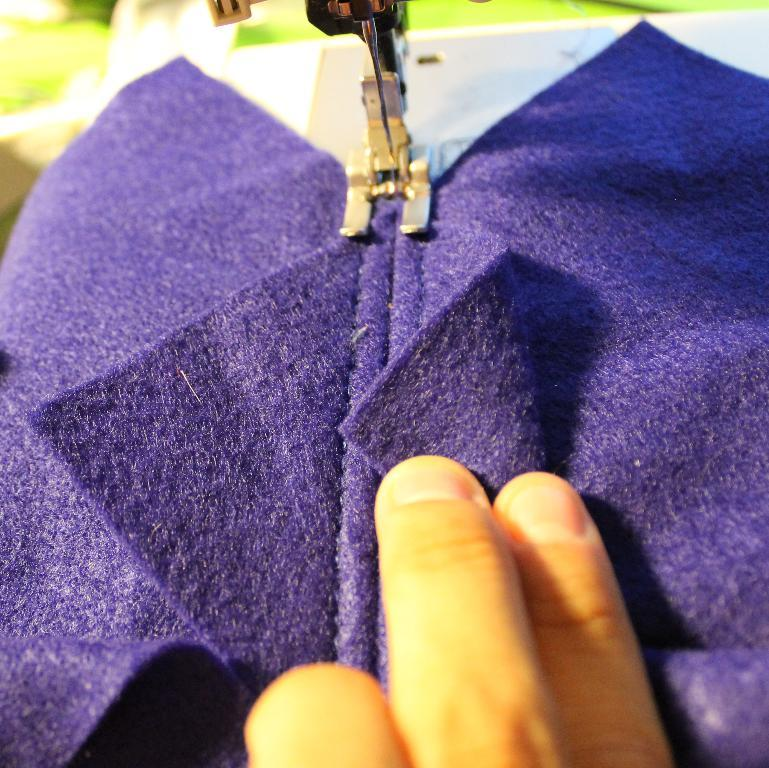What part of a person is visible in the image? The fingers of a person are visible in the image. What is the person doing with their fingers? The person is stitching a cloth. How is the cloth being stitched? The cloth is being stitched on a machine. What can be seen in the background of the image? There is a blurred background at the top of the image. What type of skate is being used to stitch the cloth in the image? There is no skate present in the image; the cloth is being stitched on a sewing machine. What is the title of the book being read by the person in the image? There is no book or person reading in the image; it shows a person's fingers stitching a cloth on a machine. 